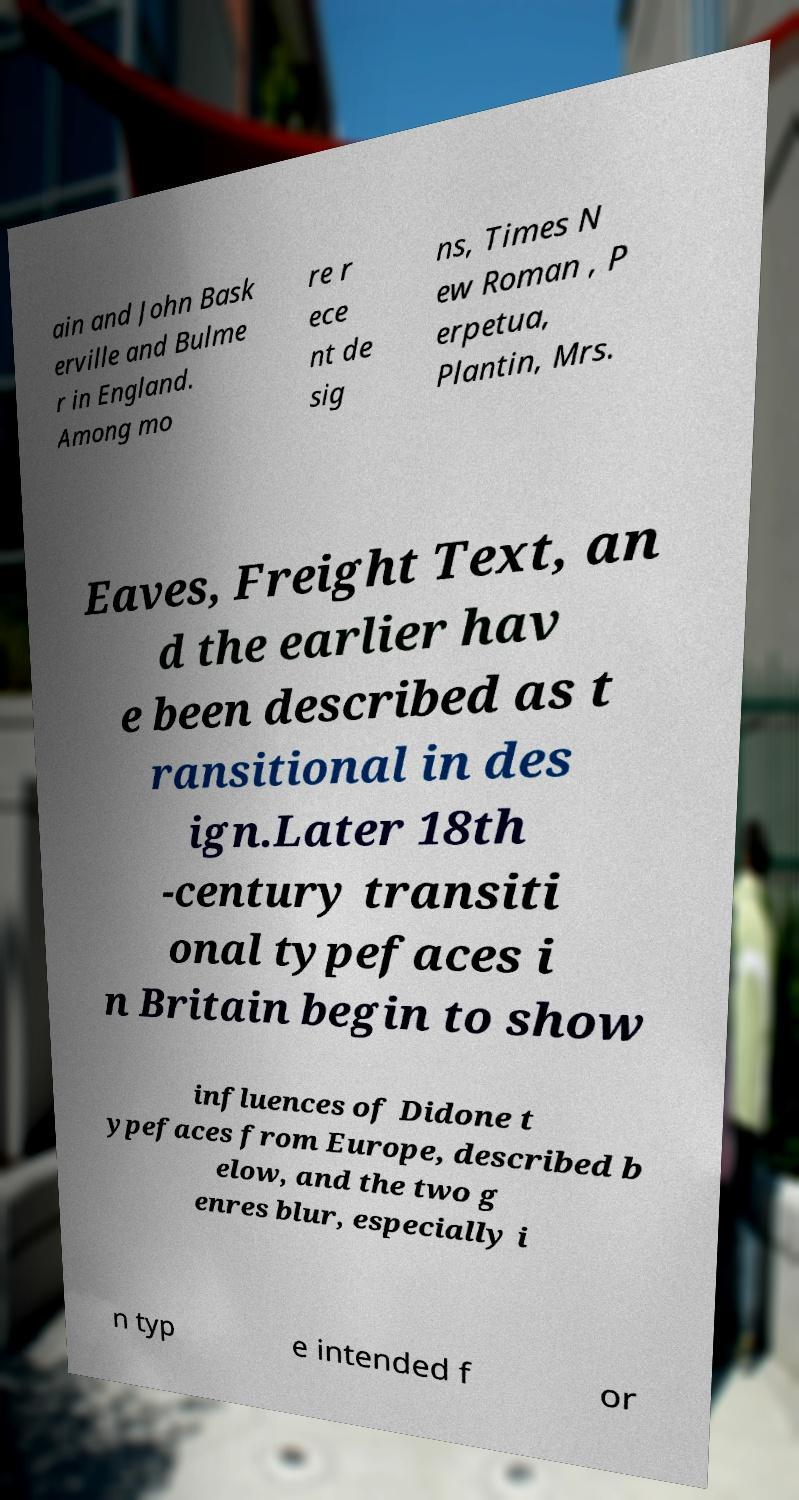Can you accurately transcribe the text from the provided image for me? ain and John Bask erville and Bulme r in England. Among mo re r ece nt de sig ns, Times N ew Roman , P erpetua, Plantin, Mrs. Eaves, Freight Text, an d the earlier hav e been described as t ransitional in des ign.Later 18th -century transiti onal typefaces i n Britain begin to show influences of Didone t ypefaces from Europe, described b elow, and the two g enres blur, especially i n typ e intended f or 